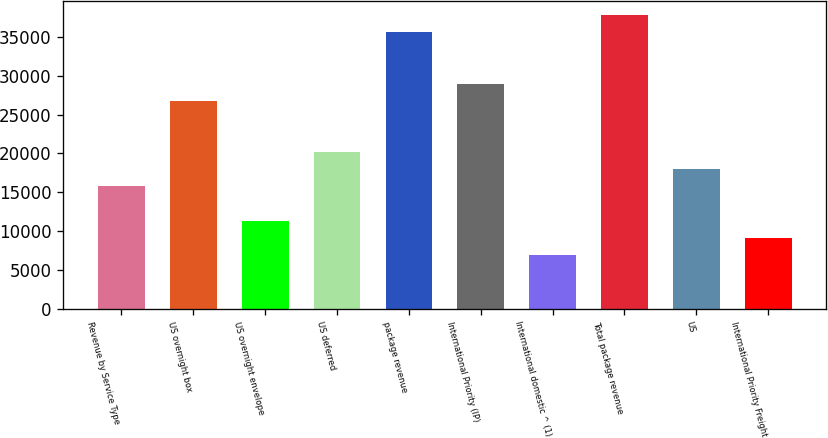Convert chart. <chart><loc_0><loc_0><loc_500><loc_500><bar_chart><fcel>Revenue by Service Type<fcel>US overnight box<fcel>US overnight envelope<fcel>US deferred<fcel>package revenue<fcel>International Priority (IP)<fcel>International domestic ^ (1)<fcel>Total package revenue<fcel>US<fcel>International Priority Freight<nl><fcel>15746.6<fcel>26775.6<fcel>11335<fcel>20158.2<fcel>35598.8<fcel>28981.4<fcel>6923.4<fcel>37804.6<fcel>17952.4<fcel>9129.2<nl></chart> 